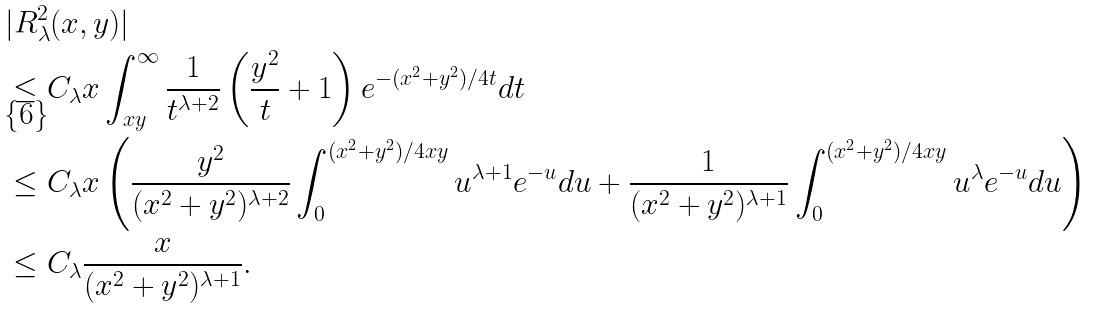Convert formula to latex. <formula><loc_0><loc_0><loc_500><loc_500>& | R _ { \lambda } ^ { 2 } ( x , y ) | \\ & \leq C _ { \lambda } x \int _ { x y } ^ { \infty } \frac { 1 } { t ^ { \lambda + 2 } } \left ( \frac { y ^ { 2 } } { t } + 1 \right ) e ^ { - ( x ^ { 2 } + y ^ { 2 } ) / 4 t } d t \\ & \leq C _ { \lambda } x \left ( \frac { y ^ { 2 } } { ( x ^ { 2 } + y ^ { 2 } ) ^ { \lambda + 2 } } \int _ { 0 } ^ { ( x ^ { 2 } + y ^ { 2 } ) / 4 x y } u ^ { \lambda + 1 } e ^ { - u } d u + \frac { 1 } { ( x ^ { 2 } + y ^ { 2 } ) ^ { \lambda + 1 } } \int _ { 0 } ^ { ( x ^ { 2 } + y ^ { 2 } ) / 4 x y } u ^ { \lambda } e ^ { - u } d u \right ) \\ & \leq C _ { \lambda } \frac { x } { ( x ^ { 2 } + y ^ { 2 } ) ^ { \lambda + 1 } } .</formula> 